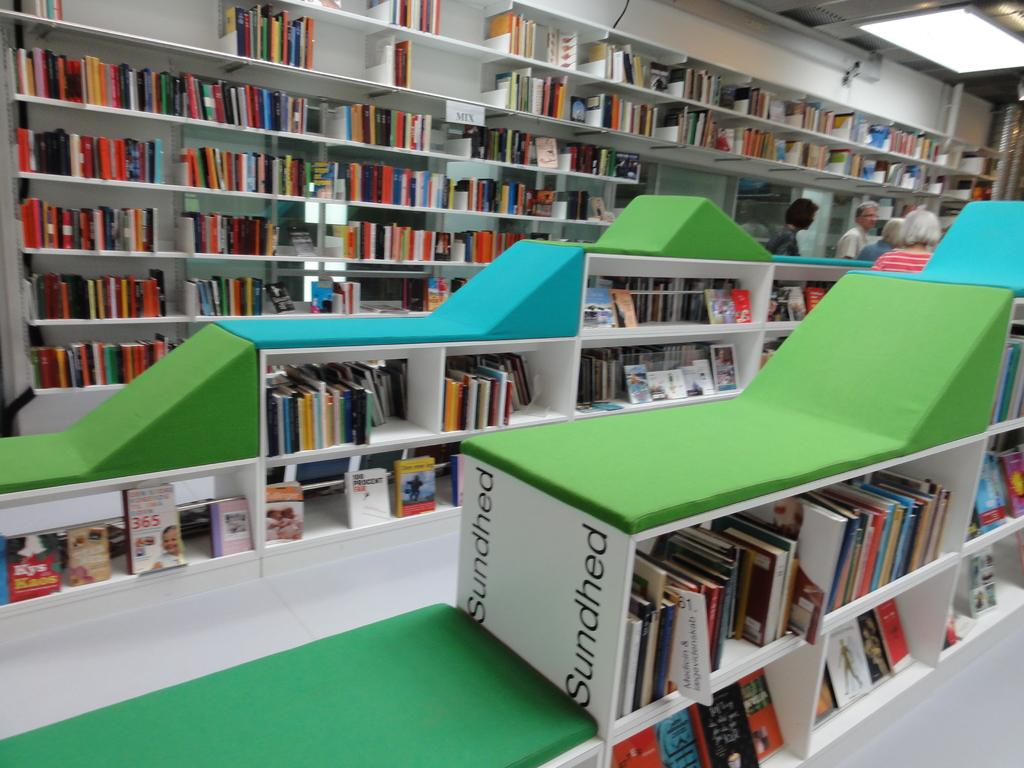<image>
Write a terse but informative summary of the picture. a white item with the word sundhed on it 